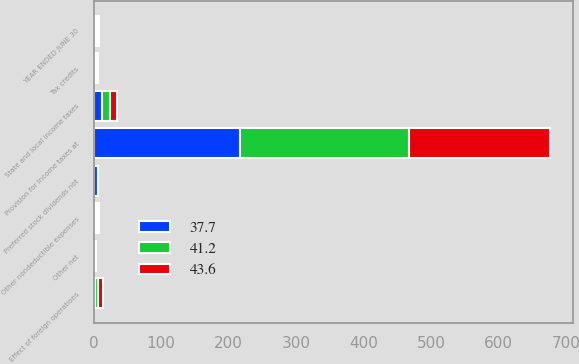Convert chart. <chart><loc_0><loc_0><loc_500><loc_500><stacked_bar_chart><ecel><fcel>YEAR ENDED JUNE 30<fcel>Provision for income taxes at<fcel>State and local income taxes<fcel>Effect of foreign operations<fcel>Preferred stock dividends not<fcel>Other nondeductible expenses<fcel>Tax credits<fcel>Other net<nl><fcel>43.6<fcel>2.7<fcel>208.5<fcel>9.7<fcel>7<fcel>0.2<fcel>3.4<fcel>2.2<fcel>2<nl><fcel>41.2<fcel>2.7<fcel>249.8<fcel>11.8<fcel>4.3<fcel>0.3<fcel>2<fcel>2.6<fcel>0.6<nl><fcel>37.7<fcel>2.7<fcel>217.6<fcel>12.7<fcel>2.7<fcel>6.1<fcel>2.7<fcel>1.3<fcel>0.7<nl></chart> 